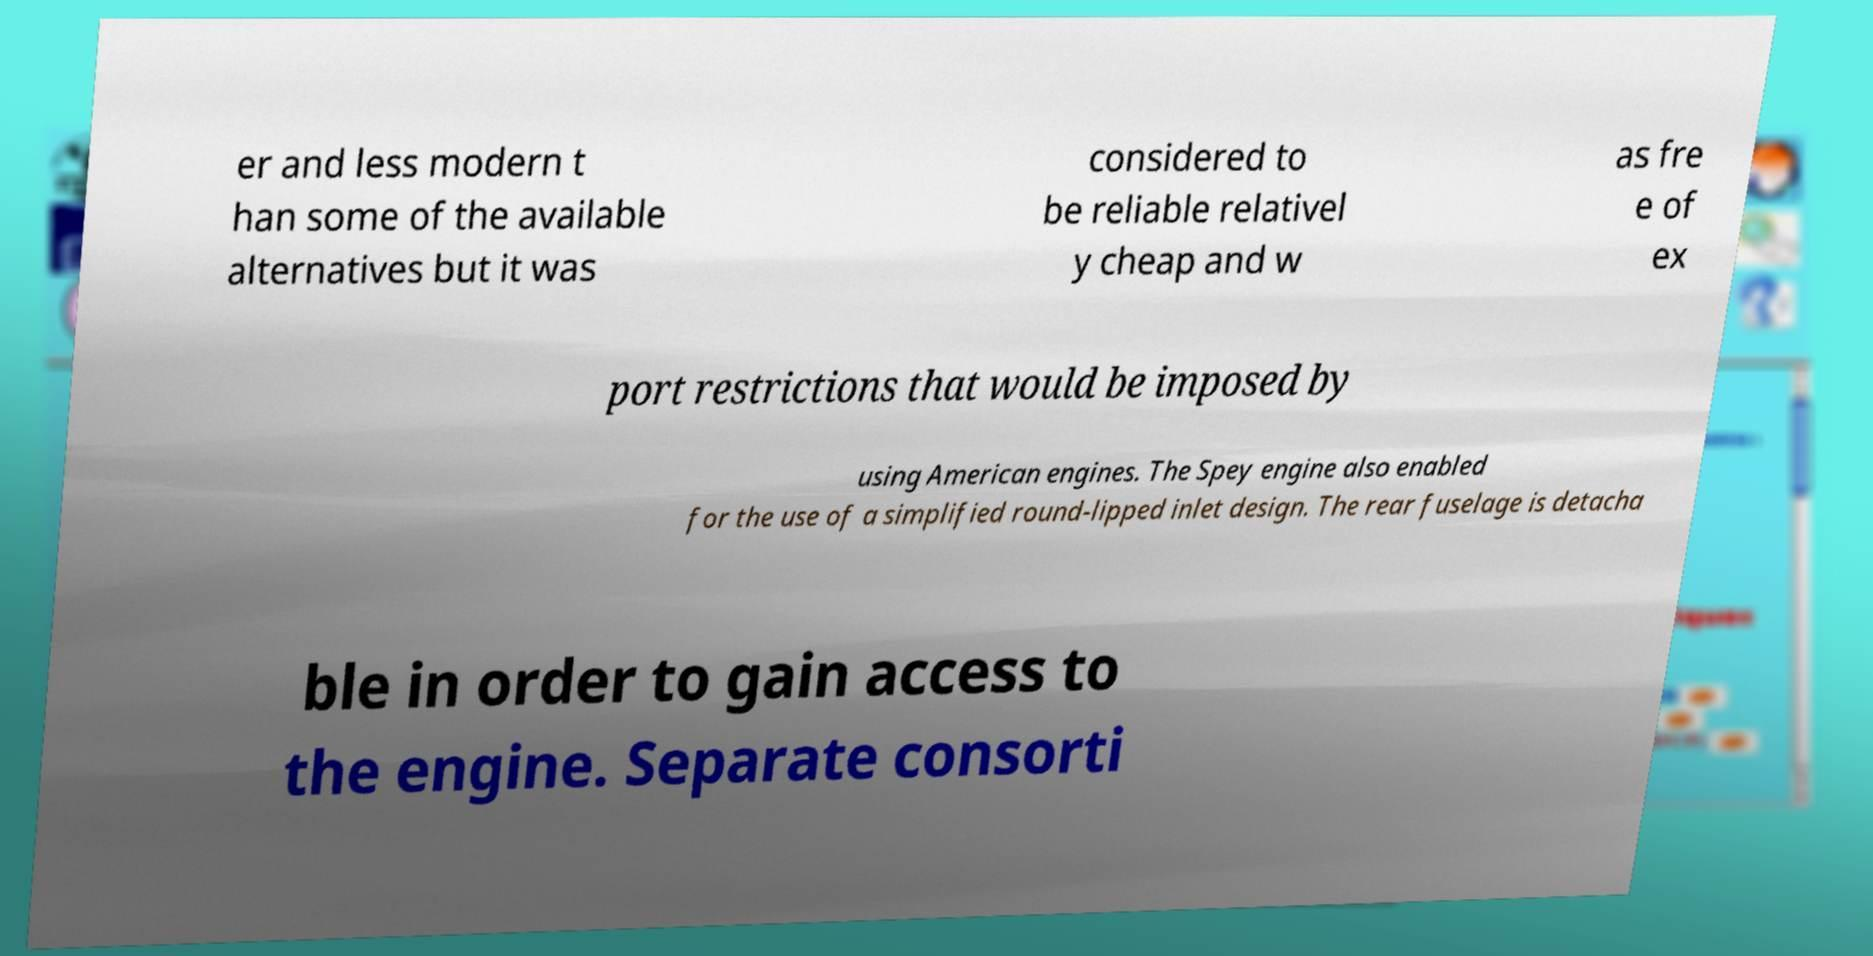Can you accurately transcribe the text from the provided image for me? er and less modern t han some of the available alternatives but it was considered to be reliable relativel y cheap and w as fre e of ex port restrictions that would be imposed by using American engines. The Spey engine also enabled for the use of a simplified round-lipped inlet design. The rear fuselage is detacha ble in order to gain access to the engine. Separate consorti 